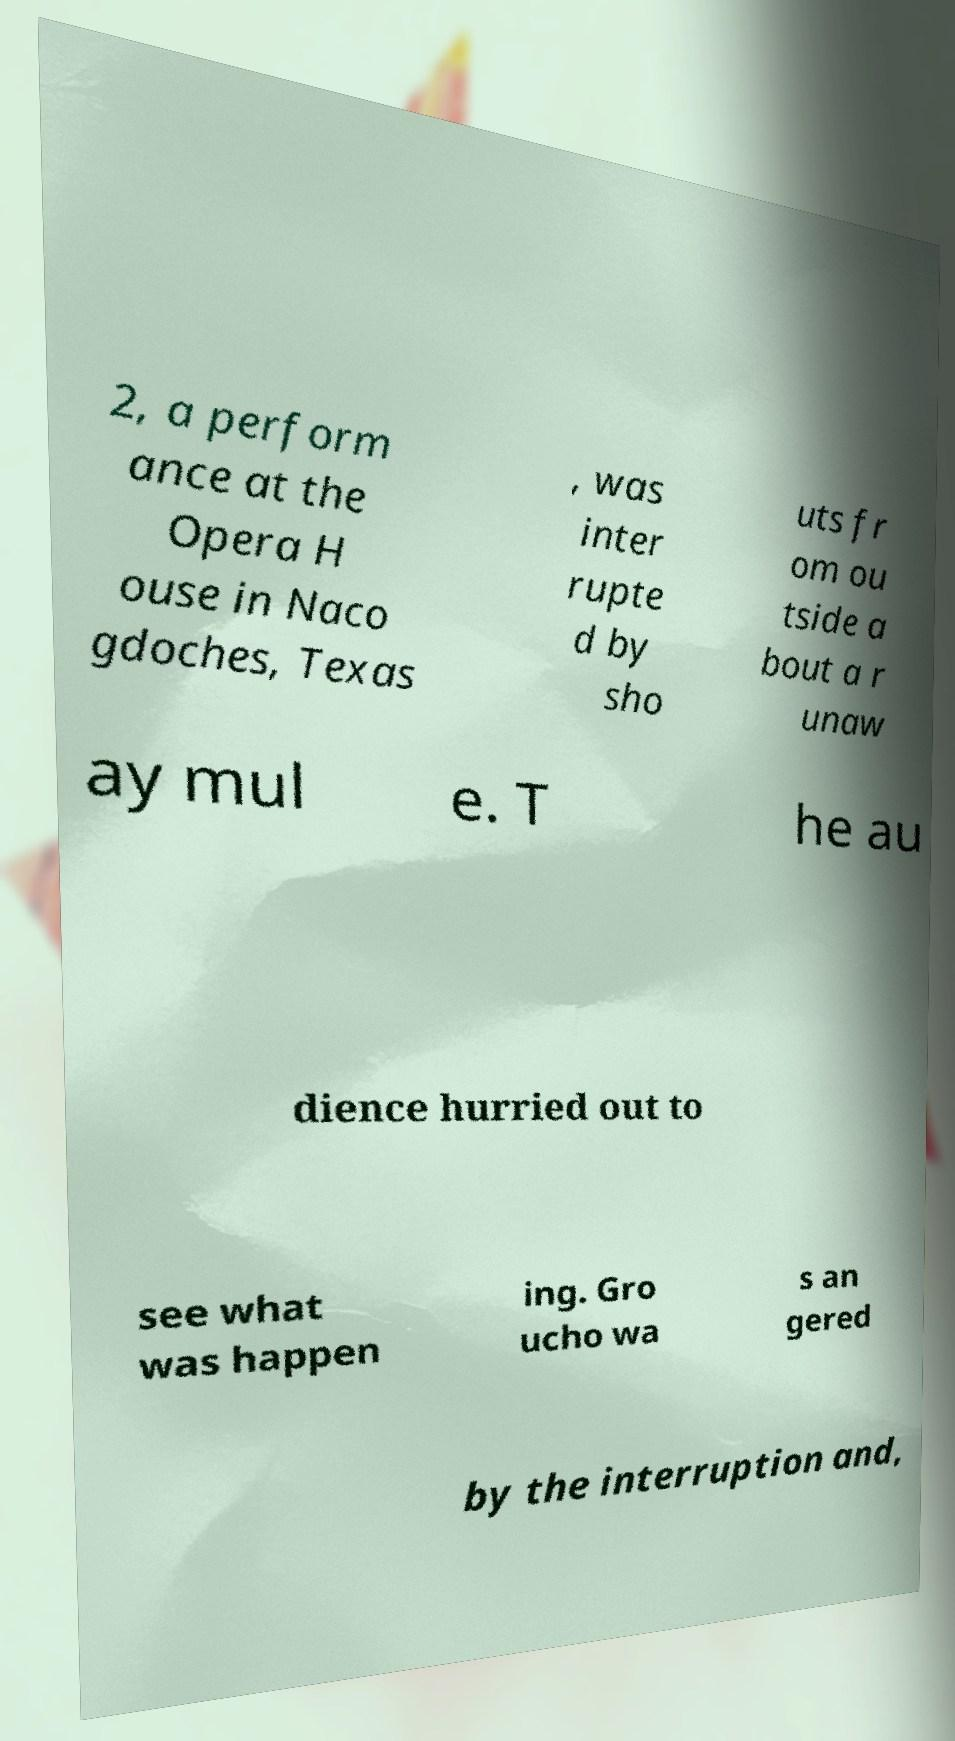Could you extract and type out the text from this image? 2, a perform ance at the Opera H ouse in Naco gdoches, Texas , was inter rupte d by sho uts fr om ou tside a bout a r unaw ay mul e. T he au dience hurried out to see what was happen ing. Gro ucho wa s an gered by the interruption and, 